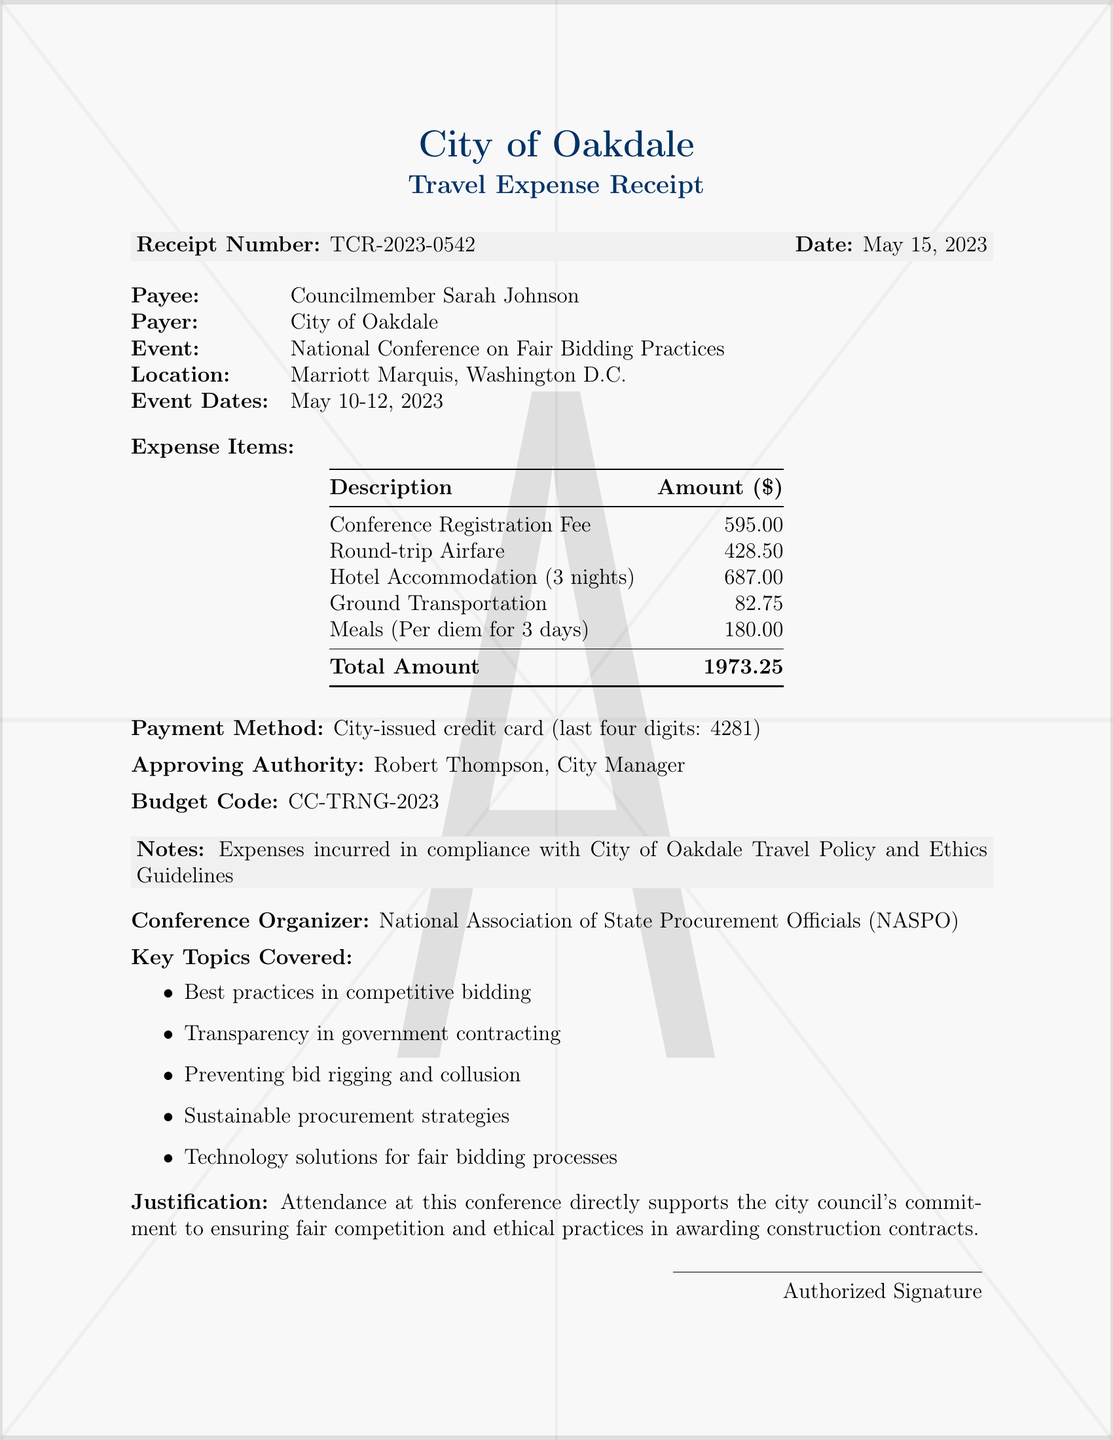What is the receipt number? The receipt number is located at the top of the document.
Answer: TCR-2023-0542 What is the date of the receipt? The date of the receipt is listed in the document.
Answer: May 15, 2023 Who is the payee? The payee is the individual who received the payment.
Answer: Councilmember Sarah Johnson What is the total amount of expenses? The total amount is calculated from the expense items listed.
Answer: 1973.25 What method of payment was used? The payment method is specified in the document.
Answer: City-issued credit card (last four digits: 4281) What event did the councilmember attend? The event is mentioned near the beginning of the document.
Answer: National Conference on Fair Bidding Practices Who approved the expenses? The approving authority is listed alongside the payment details.
Answer: Robert Thompson, City Manager What budget code is associated with these expenses? The budget code is provided in the receipt details.
Answer: CC-TRNG-2023 What is a key topic covered at the conference? Key topics are listed in the document, indicating important subjects discussed.
Answer: Best practices in competitive bidding 